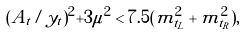Convert formula to latex. <formula><loc_0><loc_0><loc_500><loc_500>( A _ { t } / y _ { t } ) ^ { 2 } + 3 \mu ^ { 2 } < 7 . 5 ( m _ { \tilde { t } _ { L } } ^ { 2 } + m _ { \tilde { t } _ { R } } ^ { 2 } ) ,</formula> 